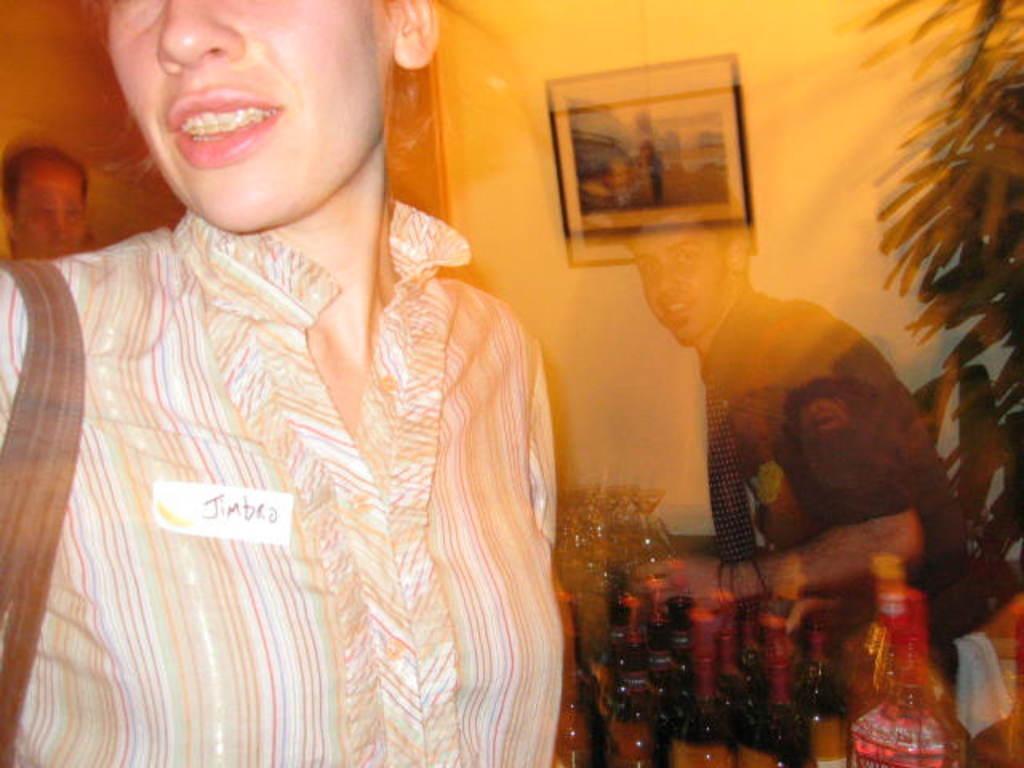Describe this image in one or two sentences. In the image we can see people wearing clothes. Here we can see bottles and wine glasses. Here we can see leaves and frame stick to the wall. 